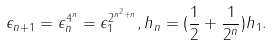Convert formula to latex. <formula><loc_0><loc_0><loc_500><loc_500>\epsilon _ { n + 1 } = \epsilon _ { n } ^ { 4 ^ { n } } = \epsilon _ { 1 } ^ { 2 ^ { n ^ { 2 } + n } } , h _ { n } = ( \frac { 1 } { 2 } + \frac { 1 } { 2 ^ { n } } ) h _ { 1 } .</formula> 